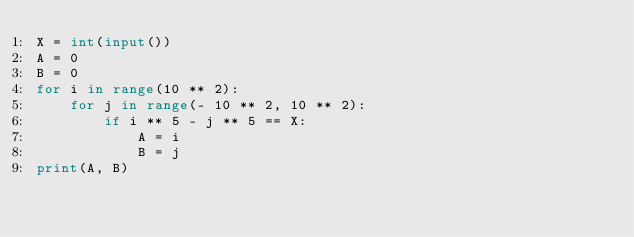Convert code to text. <code><loc_0><loc_0><loc_500><loc_500><_Python_>X = int(input())
A = 0
B = 0
for i in range(10 ** 2):
    for j in range(- 10 ** 2, 10 ** 2):
        if i ** 5 - j ** 5 == X:
            A = i
            B = j
print(A, B)</code> 